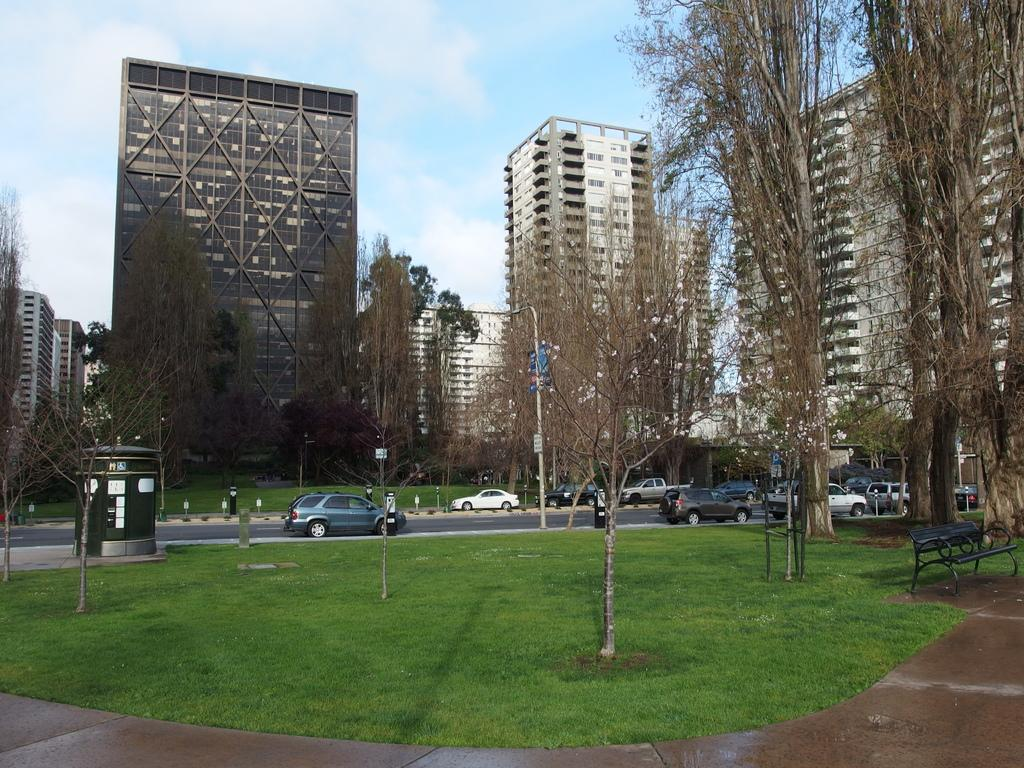What type of structures can be seen in the image? There are buildings in the image. What is happening on the road in the image? Vehicles are present on the road in the image. What type of vegetation is visible in the image? There is grass visible in the image. What type of seating is present in the image? Benches are present in the image. What can be seen in the background of the image? The sky, poles, and other objects are visible in the background of the image. What type of orange substance is dripping from the buildings in the image? There is no orange substance present in the image; the buildings are not depicted as having any dripping substances. 